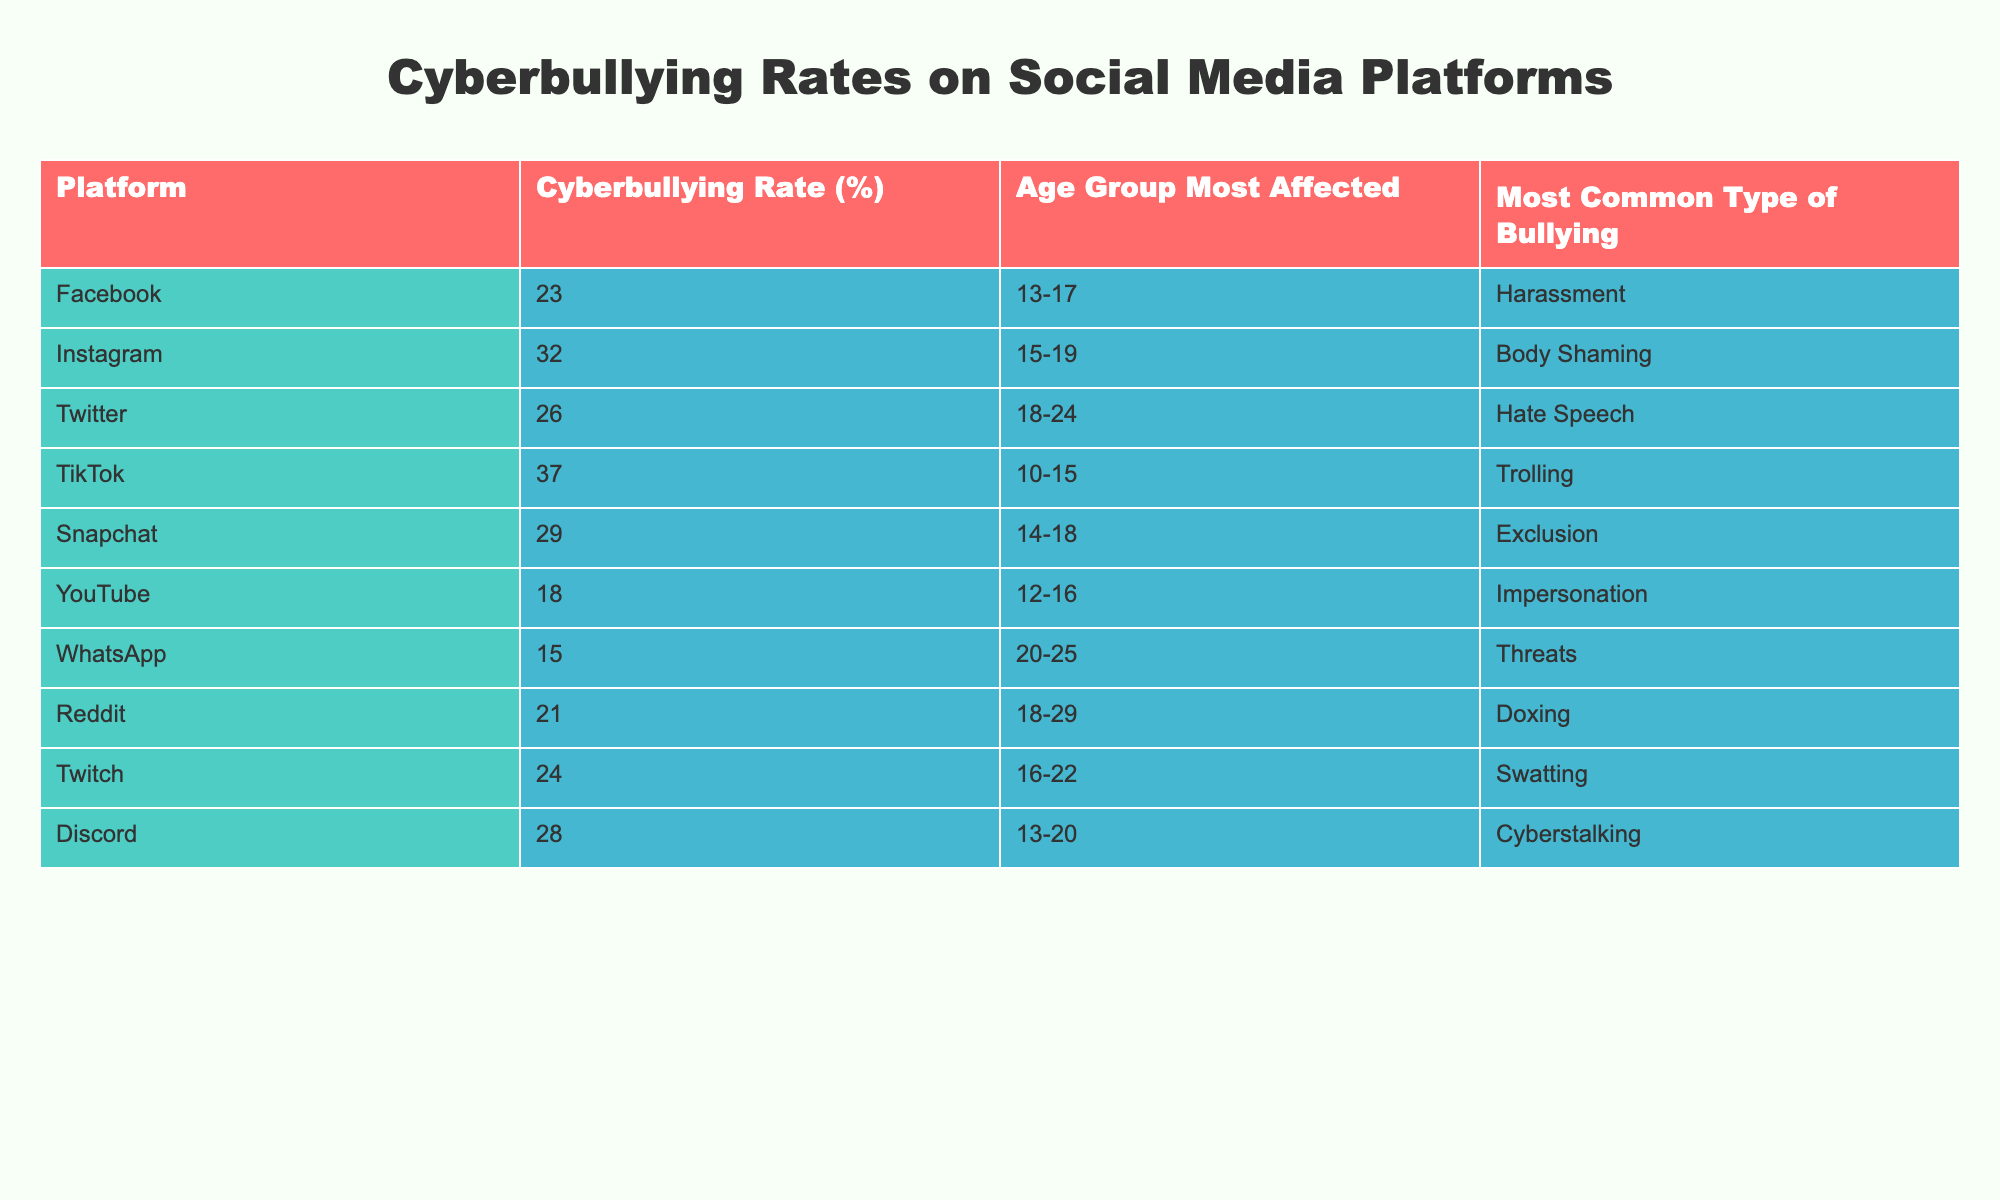What is the cyberbullying rate on Instagram? According to the table, the cyberbullying rate on Instagram is listed as 32%.
Answer: 32% Which age group is most affected by cyberbullying on TikTok? The table indicates that the age group most affected on TikTok is 10-15 years old.
Answer: 10-15 What is the most common type of bullying reported on Facebook? The table specifies that the most common type of bullying on Facebook is harassment.
Answer: Harassment What is the average cyberbullying rate across all platforms listed? To calculate the average, sum the rates: (23 + 32 + 26 + 37 + 29 + 18 + 15 + 21 + 24 + 28) =  259, and there are 10 platforms, so the average is 259/10 = 25.9%.
Answer: 25.9% Is YouTube the platform with the lowest cyberbullying rate? The table shows that YouTube has a cyberbullying rate of 18%, which is lower than the rates for all other platforms listed. Therefore, yes, it is the platform with the lowest rate.
Answer: Yes Which platform has the highest rate of cyberbullying, and what is that rate? The table states that TikTok has the highest cyberbullying rate at 37%.
Answer: TikTok, 37% How do the cyberbullying rates on Snapchat and Discord compare? Snapchat has a rate of 29%, while Discord has a rate of 28%. Snapchat's rate is higher than Discord's by 1 percentage point.
Answer: Snapchat is higher by 1% What is the difference between the cyberbullying rates of Instagram and Twitter? Instagram's rate is 32%, and Twitter's rate is 26%. The difference is 32 - 26 = 6 percentage points.
Answer: 6 In which age group is body shaming most prevalent, according to the data? The table notes that body shaming is most common on Instagram, affecting the age group 15-19.
Answer: 15-19 Does the table indicate that WhatsApp has a higher cyberbullying rate than YouTube? The rate for WhatsApp is 15% and for YouTube is 18%. Since 15% is less than 18%, WhatsApp does not have a higher rate.
Answer: No 